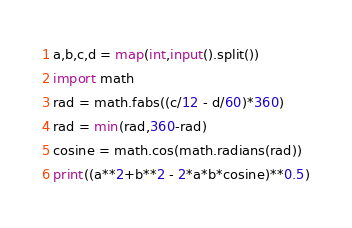<code> <loc_0><loc_0><loc_500><loc_500><_Python_>a,b,c,d = map(int,input().split())
import math
rad = math.fabs((c/12 - d/60)*360)
rad = min(rad,360-rad)
cosine = math.cos(math.radians(rad))
print((a**2+b**2 - 2*a*b*cosine)**0.5)</code> 